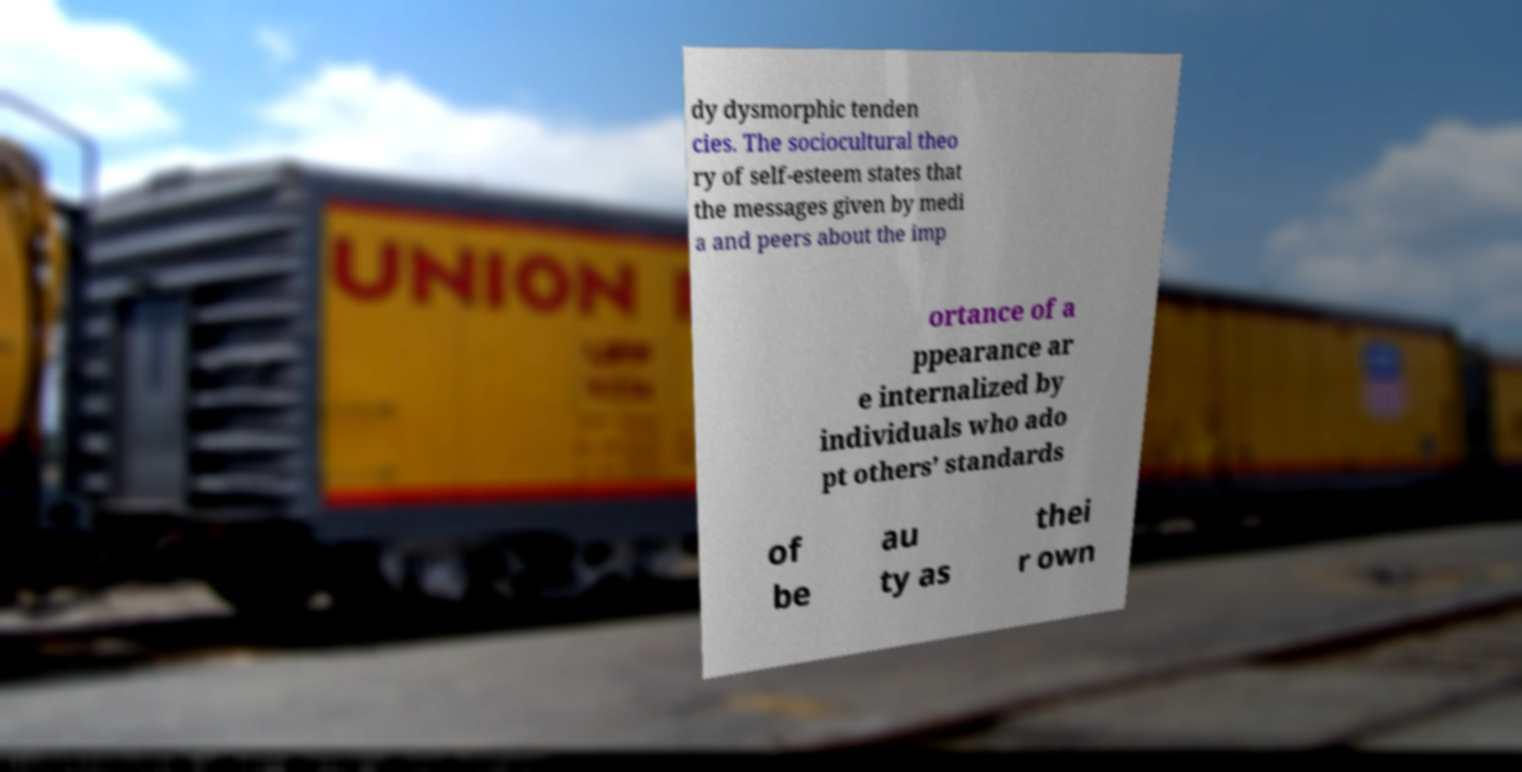What messages or text are displayed in this image? I need them in a readable, typed format. dy dysmorphic tenden cies. The sociocultural theo ry of self-esteem states that the messages given by medi a and peers about the imp ortance of a ppearance ar e internalized by individuals who ado pt others’ standards of be au ty as thei r own 